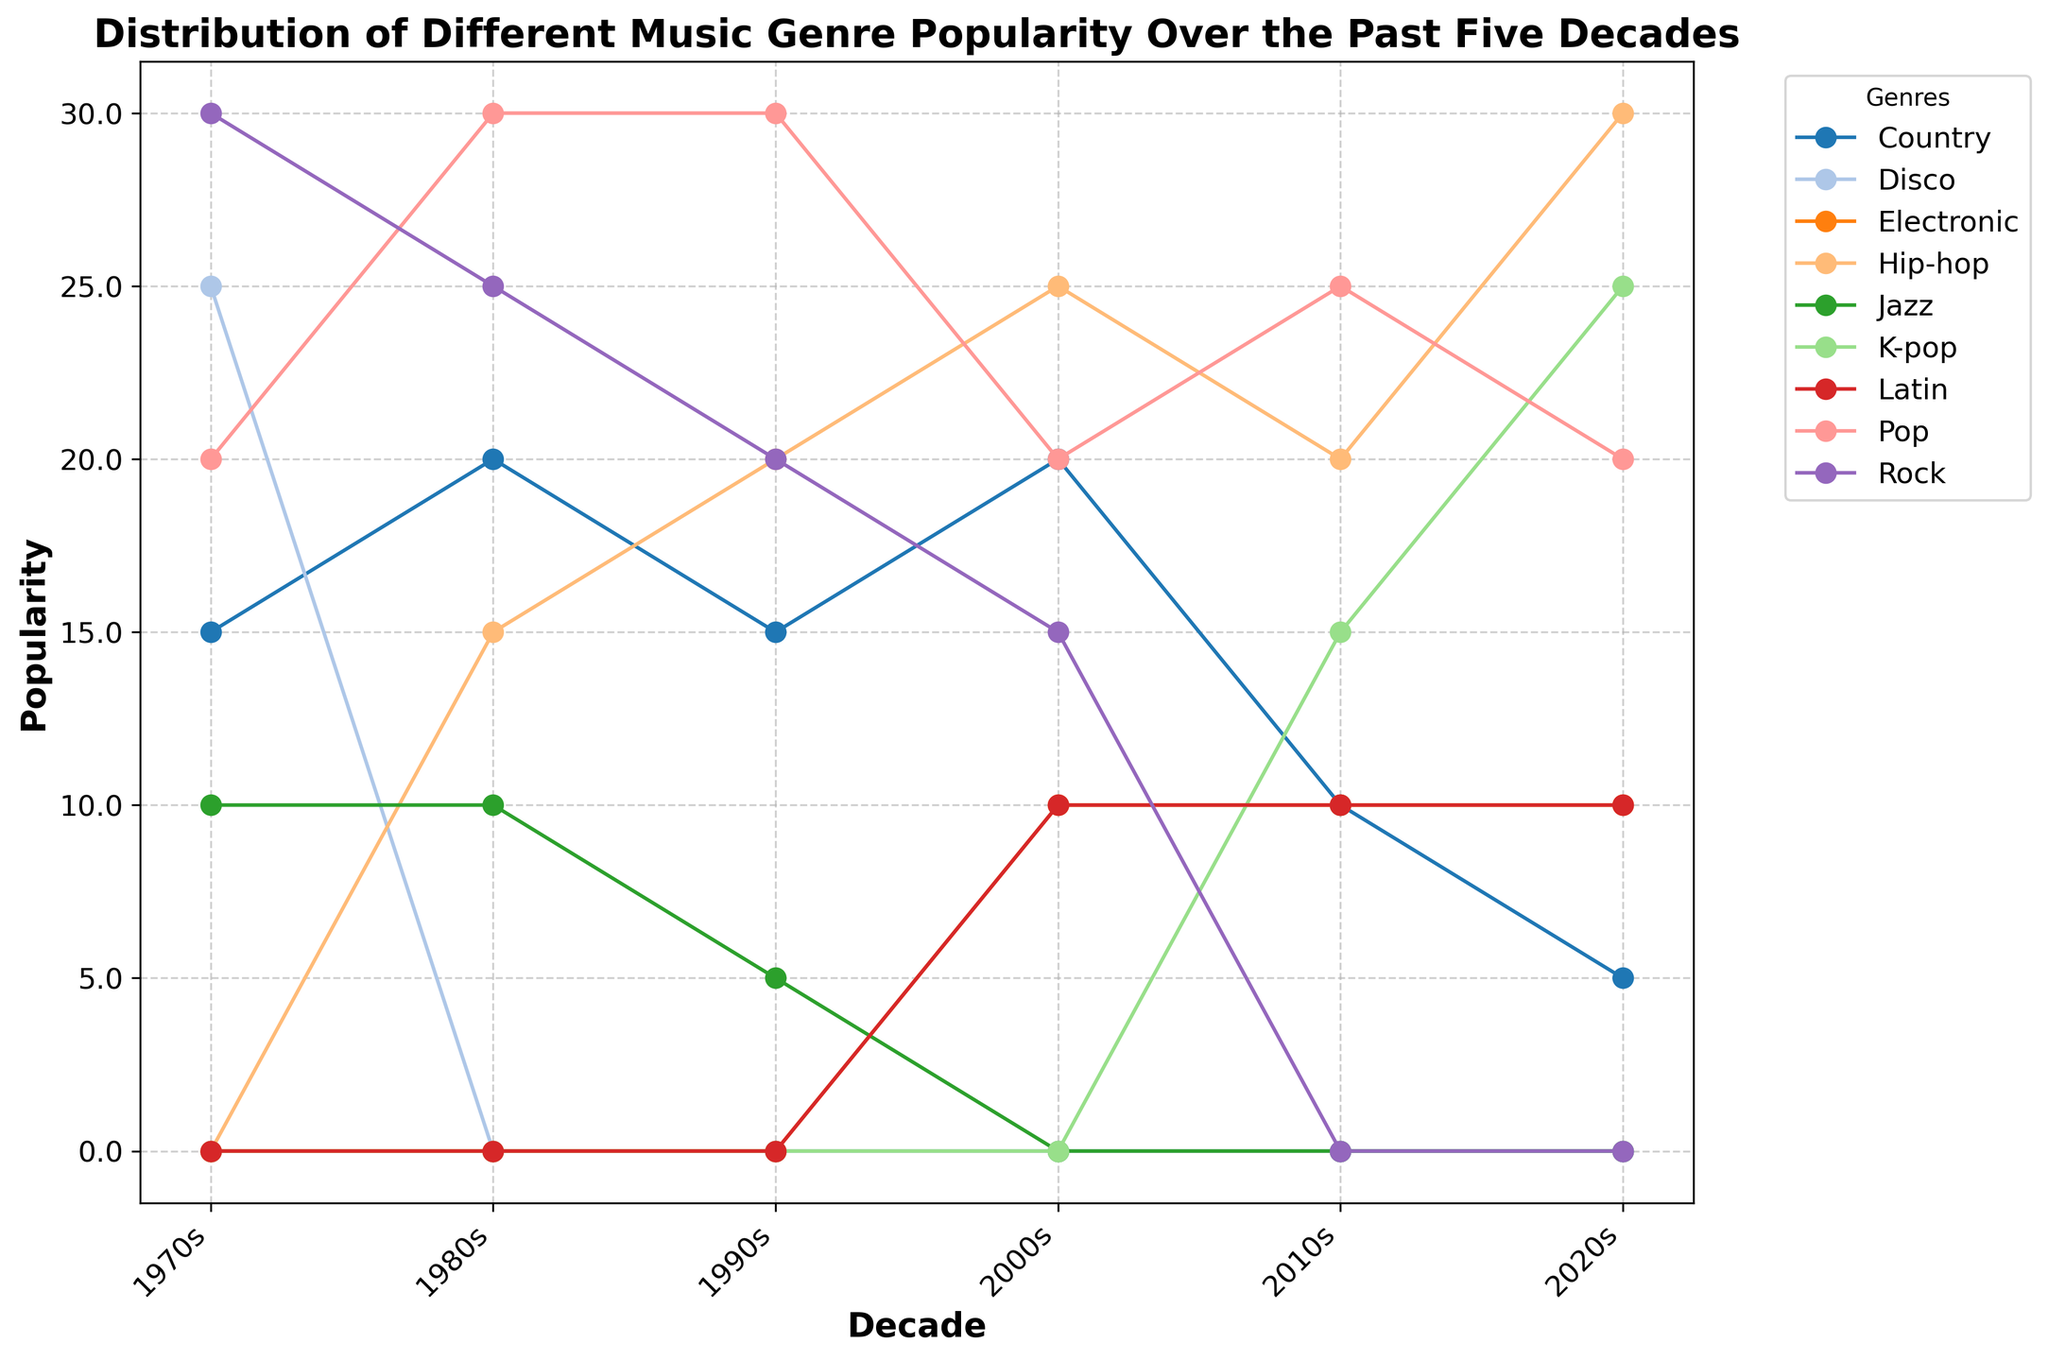What genre was most popular in the 1970s? Look at the height of the lines representing each genre in the 1970s. The genre with the highest value is the most popular in that decade. Rock reaches the highest point at 30.
Answer: Rock Which genre saw the highest increase in popularity from the 2000s to the 2020s? Compare the popularity values of each genre in the 2000s and 2020s and find the one with the greatest difference. K-pop increases from 0 in the 2000s to 25 in the 2020s, which is the highest increase.
Answer: K-pop How did the popularity of Jazz change from the 1970s to the 1990s? Look at the data points for Jazz across the 1970s, 1980s, and 1990s. In the 1970s, Jazz was at 10, and it decreased slightly to 5 by the 1990s.
Answer: Decreased Which decade had the most diverse music scene, considering the number of genres with significant popularity? Count the number of distinct genres with relatively high popularity values in each decade. The 2010s and 2020s both have six different genres with significant popularity values.
Answer: 2010s, 2020s In which decade did Hip-hop first appear, and what was its popularity at that time? Trace Hip-hop lines back through the decades to see when they first non-zero data point appeared. Hip-hop first appears in the 1980s with a value of 15.
Answer: 1980s, 15 Compare the popularity of Rock and Pop in the 1980s. Which was more popular and by how much? Look at the heights of the lines representing Rock and Pop in the 1980s. Pop is at 30, whereas Rock is at 25. The difference is 5.
Answer: Pop, 5 What was the second most popular genre in the 2020s? Examine the heights of all the genre lines in the 2020s. Hip-hop is the highest, and K-pop is the second highest at 25.
Answer: K-pop How much did the popularity of Country music change from the 1970s to the 2020s? Observe the data points for Country music in these two decades. Country is at 15 in the 1970s and 5 in the 2020s. The decrease is 10.
Answer: Decreased by 10 